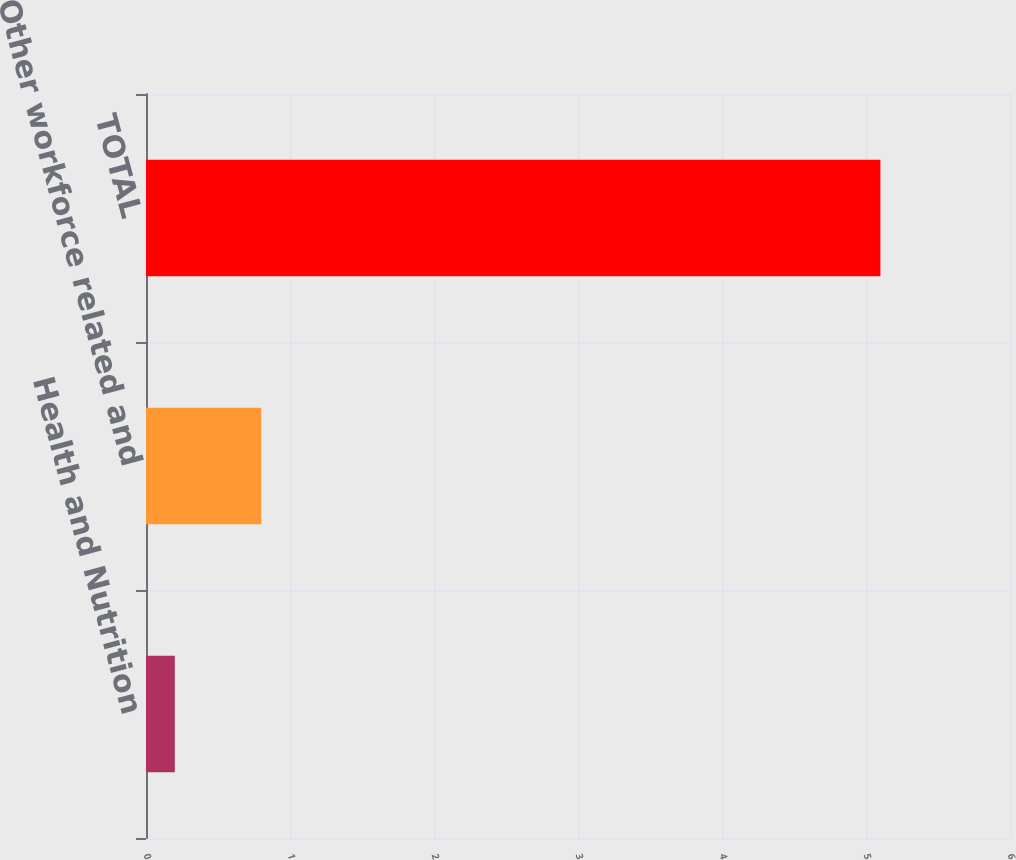<chart> <loc_0><loc_0><loc_500><loc_500><bar_chart><fcel>Health and Nutrition<fcel>Other workforce related and<fcel>TOTAL<nl><fcel>0.2<fcel>0.8<fcel>5.1<nl></chart> 